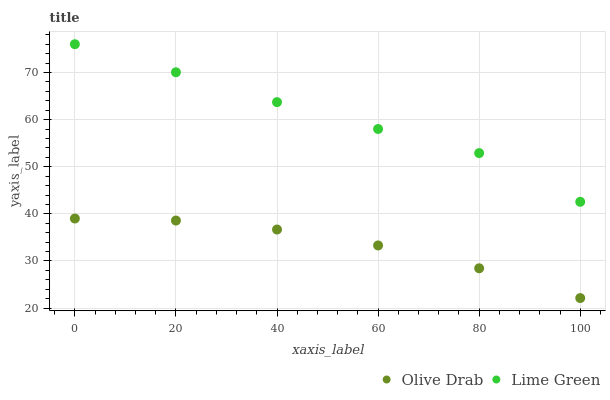Does Olive Drab have the minimum area under the curve?
Answer yes or no. Yes. Does Lime Green have the maximum area under the curve?
Answer yes or no. Yes. Does Olive Drab have the maximum area under the curve?
Answer yes or no. No. Is Olive Drab the smoothest?
Answer yes or no. Yes. Is Lime Green the roughest?
Answer yes or no. Yes. Is Olive Drab the roughest?
Answer yes or no. No. Does Olive Drab have the lowest value?
Answer yes or no. Yes. Does Lime Green have the highest value?
Answer yes or no. Yes. Does Olive Drab have the highest value?
Answer yes or no. No. Is Olive Drab less than Lime Green?
Answer yes or no. Yes. Is Lime Green greater than Olive Drab?
Answer yes or no. Yes. Does Olive Drab intersect Lime Green?
Answer yes or no. No. 